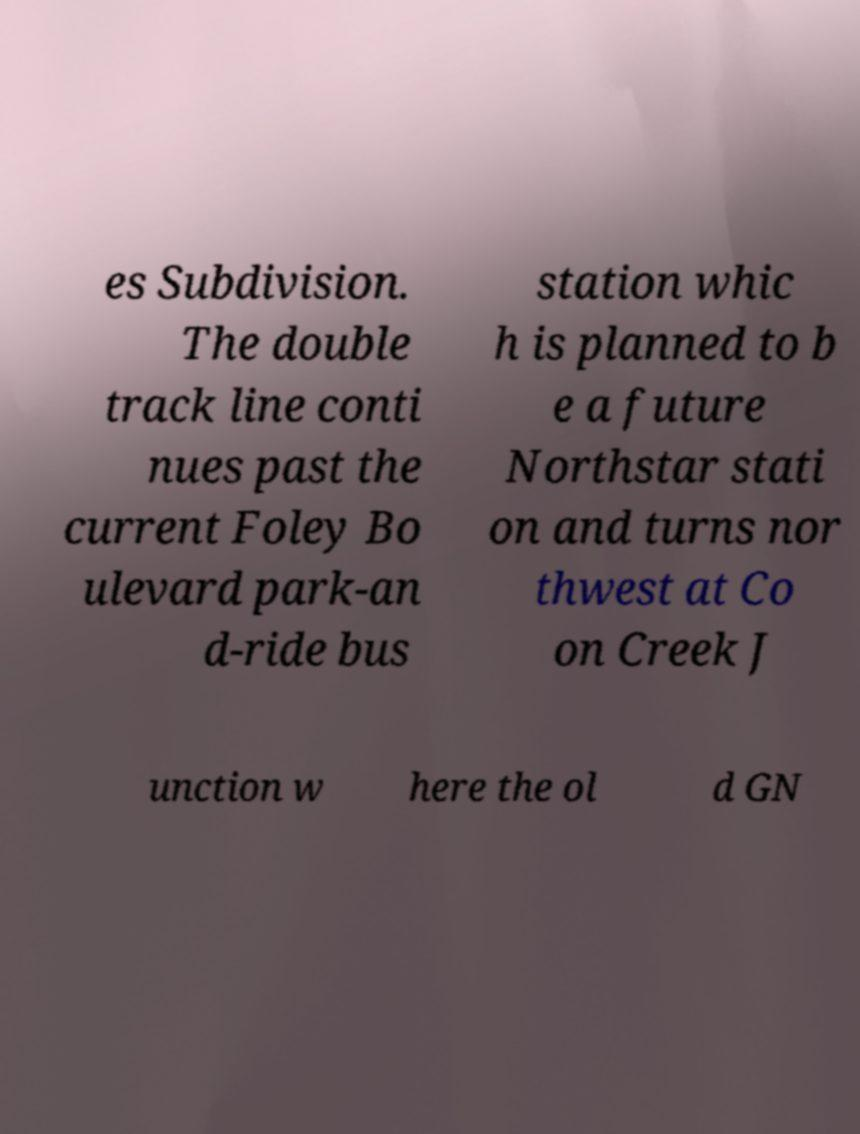Can you accurately transcribe the text from the provided image for me? es Subdivision. The double track line conti nues past the current Foley Bo ulevard park-an d-ride bus station whic h is planned to b e a future Northstar stati on and turns nor thwest at Co on Creek J unction w here the ol d GN 